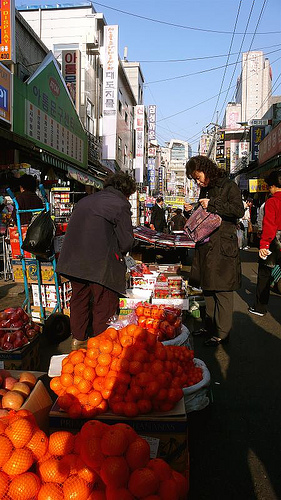Please provide a short description for this region: [0.22, 0.82, 0.6, 1.0]. This region displays a vibrant display of oranges, neatly arranged in baskets at the market stall, reflecting a busy market scene. 